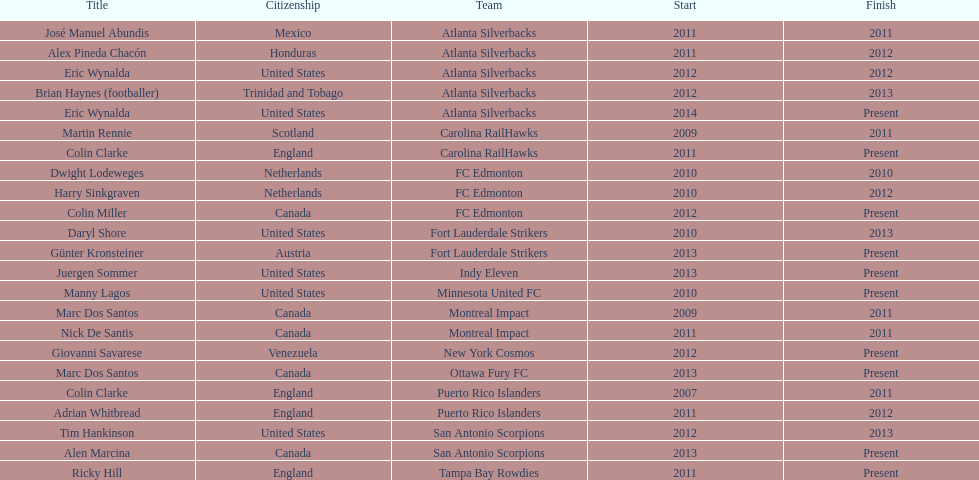Parse the table in full. {'header': ['Title', 'Citizenship', 'Team', 'Start', 'Finish'], 'rows': [['José Manuel Abundis', 'Mexico', 'Atlanta Silverbacks', '2011', '2011'], ['Alex Pineda Chacón', 'Honduras', 'Atlanta Silverbacks', '2011', '2012'], ['Eric Wynalda', 'United States', 'Atlanta Silverbacks', '2012', '2012'], ['Brian Haynes (footballer)', 'Trinidad and Tobago', 'Atlanta Silverbacks', '2012', '2013'], ['Eric Wynalda', 'United States', 'Atlanta Silverbacks', '2014', 'Present'], ['Martin Rennie', 'Scotland', 'Carolina RailHawks', '2009', '2011'], ['Colin Clarke', 'England', 'Carolina RailHawks', '2011', 'Present'], ['Dwight Lodeweges', 'Netherlands', 'FC Edmonton', '2010', '2010'], ['Harry Sinkgraven', 'Netherlands', 'FC Edmonton', '2010', '2012'], ['Colin Miller', 'Canada', 'FC Edmonton', '2012', 'Present'], ['Daryl Shore', 'United States', 'Fort Lauderdale Strikers', '2010', '2013'], ['Günter Kronsteiner', 'Austria', 'Fort Lauderdale Strikers', '2013', 'Present'], ['Juergen Sommer', 'United States', 'Indy Eleven', '2013', 'Present'], ['Manny Lagos', 'United States', 'Minnesota United FC', '2010', 'Present'], ['Marc Dos Santos', 'Canada', 'Montreal Impact', '2009', '2011'], ['Nick De Santis', 'Canada', 'Montreal Impact', '2011', '2011'], ['Giovanni Savarese', 'Venezuela', 'New York Cosmos', '2012', 'Present'], ['Marc Dos Santos', 'Canada', 'Ottawa Fury FC', '2013', 'Present'], ['Colin Clarke', 'England', 'Puerto Rico Islanders', '2007', '2011'], ['Adrian Whitbread', 'England', 'Puerto Rico Islanders', '2011', '2012'], ['Tim Hankinson', 'United States', 'San Antonio Scorpions', '2012', '2013'], ['Alen Marcina', 'Canada', 'San Antonio Scorpions', '2013', 'Present'], ['Ricky Hill', 'England', 'Tampa Bay Rowdies', '2011', 'Present']]} What same country did marc dos santos coach as colin miller? Canada. 